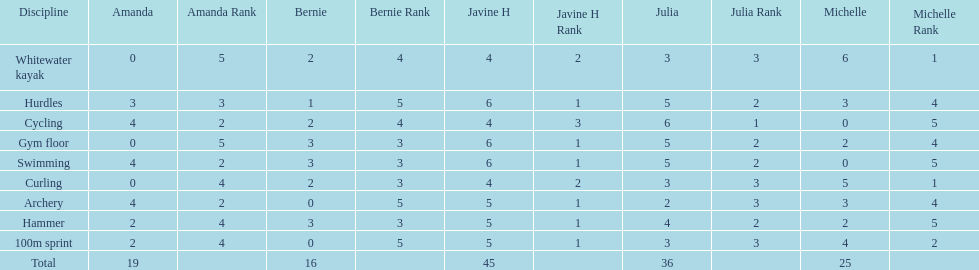Who earned the most total points? Javine H. 